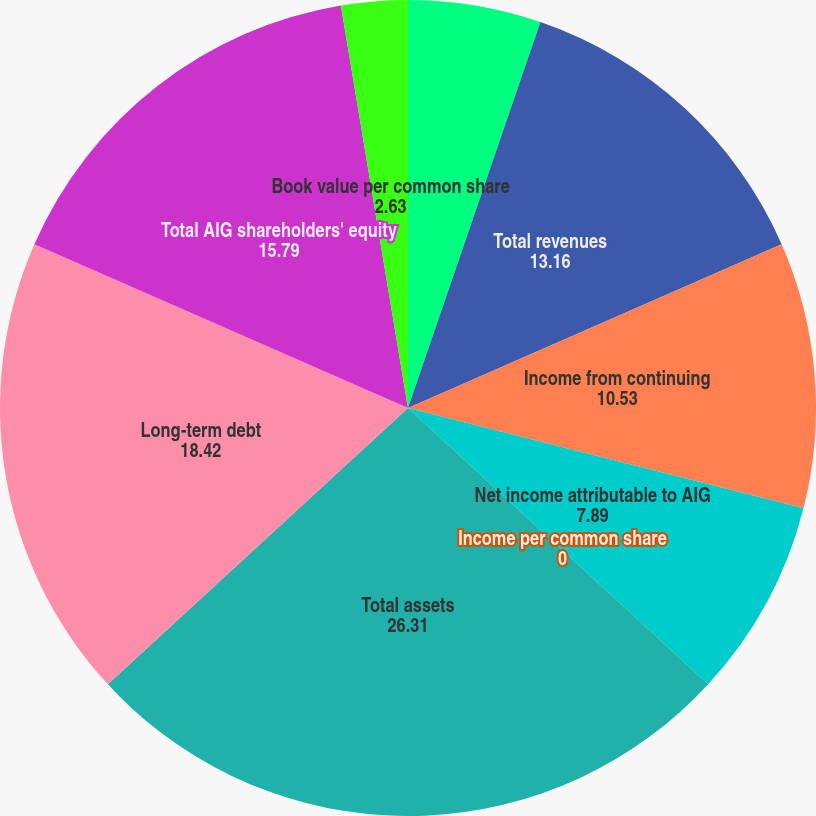<chart> <loc_0><loc_0><loc_500><loc_500><pie_chart><fcel>Years Ended December 31 (in<fcel>Total revenues<fcel>Income from continuing<fcel>Net income attributable to AIG<fcel>Income per common share<fcel>Total assets<fcel>Long-term debt<fcel>Total AIG shareholders' equity<fcel>Book value per common share<nl><fcel>5.26%<fcel>13.16%<fcel>10.53%<fcel>7.89%<fcel>0.0%<fcel>26.31%<fcel>18.42%<fcel>15.79%<fcel>2.63%<nl></chart> 